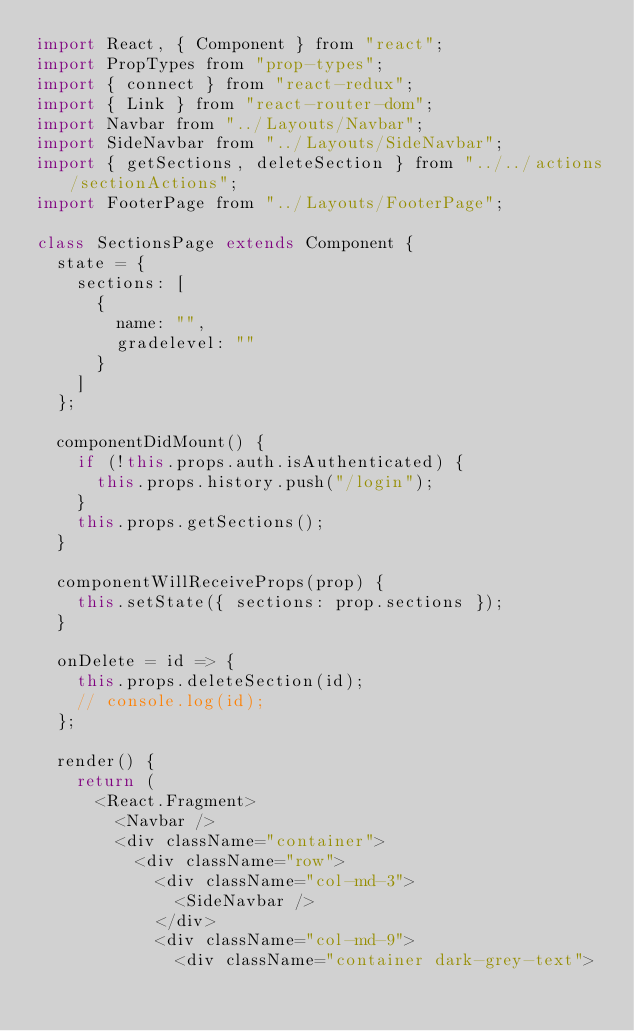<code> <loc_0><loc_0><loc_500><loc_500><_JavaScript_>import React, { Component } from "react";
import PropTypes from "prop-types";
import { connect } from "react-redux";
import { Link } from "react-router-dom";
import Navbar from "../Layouts/Navbar";
import SideNavbar from "../Layouts/SideNavbar";
import { getSections, deleteSection } from "../../actions/sectionActions";
import FooterPage from "../Layouts/FooterPage";

class SectionsPage extends Component {
  state = {
    sections: [
      {
        name: "",
        gradelevel: ""
      }
    ]
  };

  componentDidMount() {
    if (!this.props.auth.isAuthenticated) {
      this.props.history.push("/login");
    }
    this.props.getSections();
  }

  componentWillReceiveProps(prop) {
    this.setState({ sections: prop.sections });
  }

  onDelete = id => {
    this.props.deleteSection(id);
    // console.log(id);
  };

  render() {
    return (
      <React.Fragment>
        <Navbar />
        <div className="container">
          <div className="row">
            <div className="col-md-3">
              <SideNavbar />
            </div>
            <div className="col-md-9">
              <div className="container dark-grey-text"></code> 